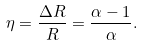Convert formula to latex. <formula><loc_0><loc_0><loc_500><loc_500>\eta = \frac { \Delta R } { R } = \frac { \alpha - 1 } { \alpha } .</formula> 